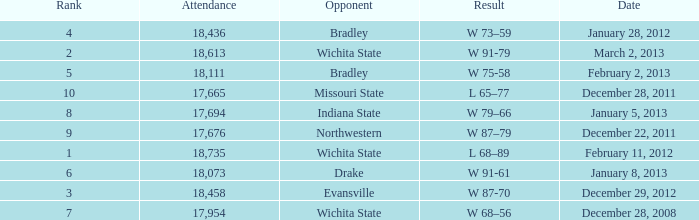What's the rank when attendance was less than 18,073 and having Northwestern as an opponent? 9.0. 